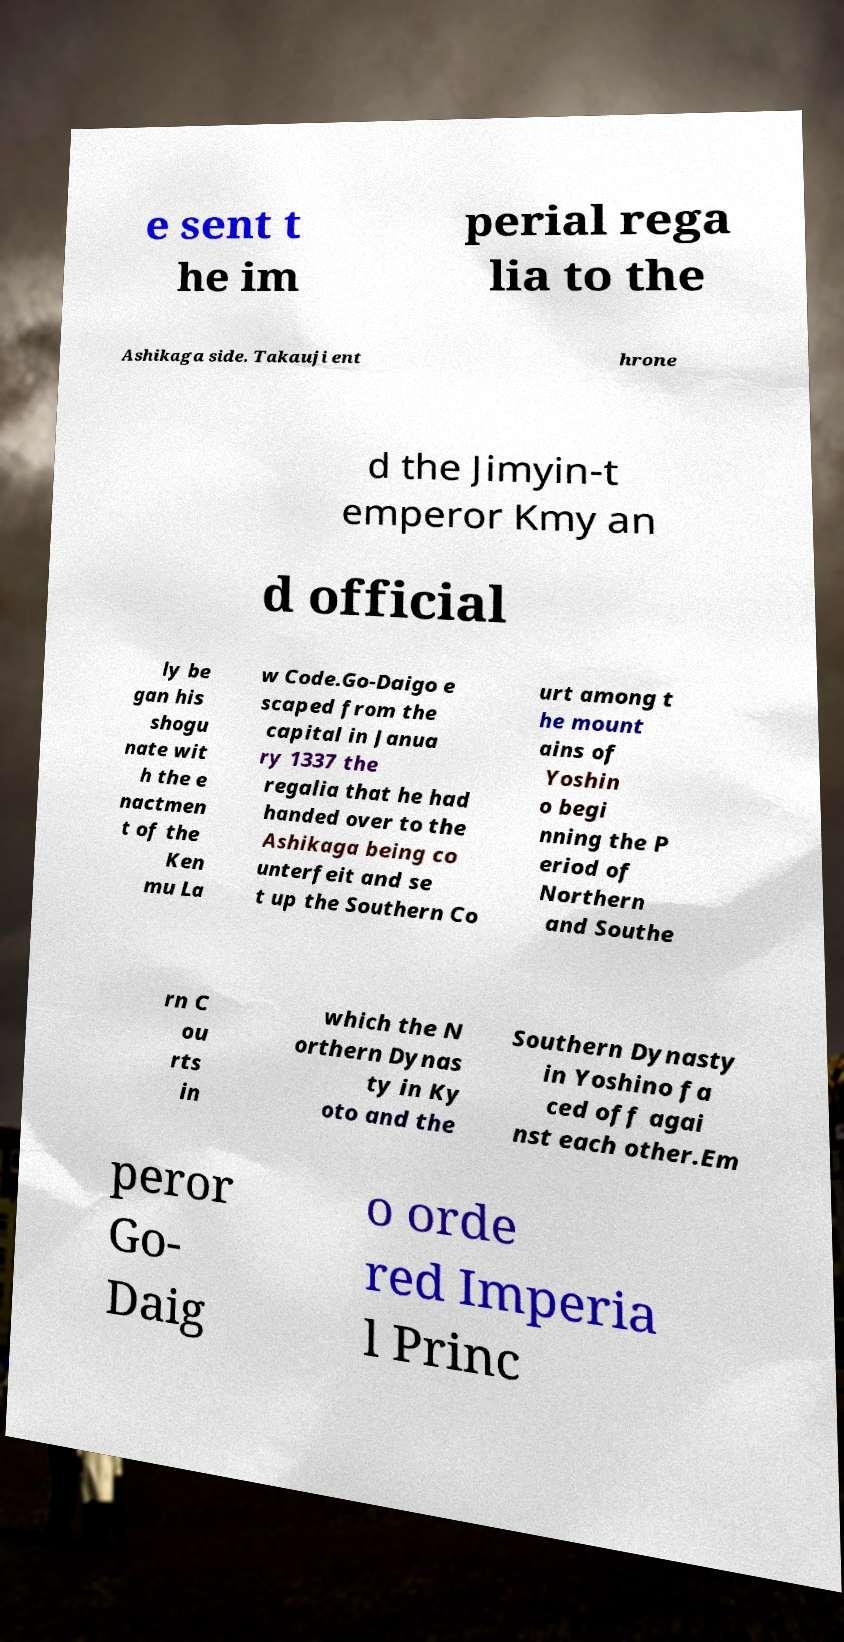What messages or text are displayed in this image? I need them in a readable, typed format. e sent t he im perial rega lia to the Ashikaga side. Takauji ent hrone d the Jimyin-t emperor Kmy an d official ly be gan his shogu nate wit h the e nactmen t of the Ken mu La w Code.Go-Daigo e scaped from the capital in Janua ry 1337 the regalia that he had handed over to the Ashikaga being co unterfeit and se t up the Southern Co urt among t he mount ains of Yoshin o begi nning the P eriod of Northern and Southe rn C ou rts in which the N orthern Dynas ty in Ky oto and the Southern Dynasty in Yoshino fa ced off agai nst each other.Em peror Go- Daig o orde red Imperia l Princ 